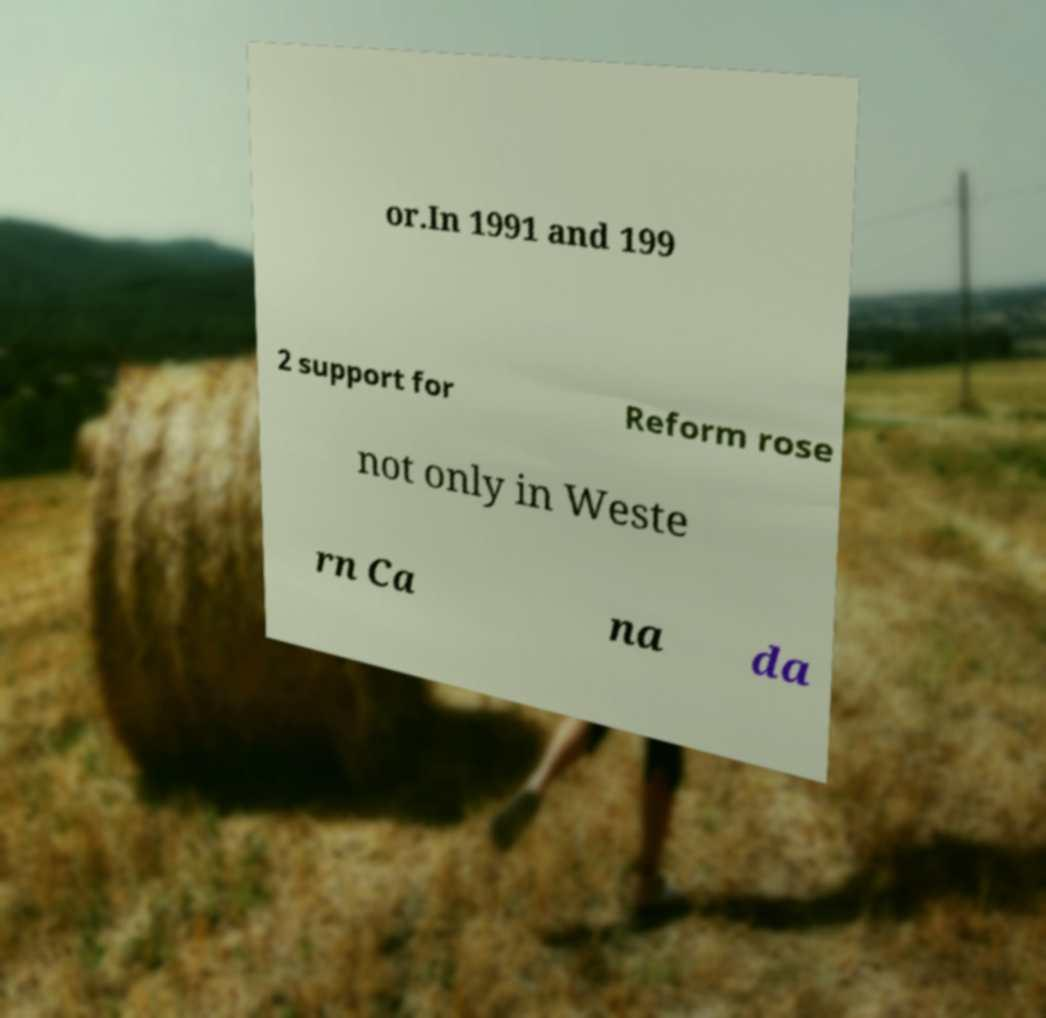I need the written content from this picture converted into text. Can you do that? or.In 1991 and 199 2 support for Reform rose not only in Weste rn Ca na da 